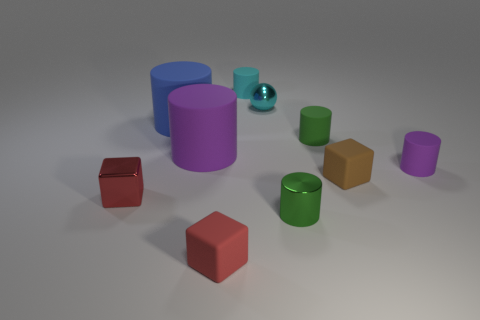There is a tiny thing that is the same color as the tiny ball; what is it made of?
Make the answer very short. Rubber. Is the size of the cyan sphere the same as the purple rubber cylinder that is left of the small cyan rubber thing?
Give a very brief answer. No. What number of metal things are either small green cylinders or tiny red things?
Your answer should be compact. 2. Are there more rubber objects than large gray rubber things?
Keep it short and to the point. Yes. The object that is the same color as the metallic block is what size?
Provide a short and direct response. Small. What is the shape of the shiny thing that is behind the purple thing that is in front of the big purple rubber cylinder?
Your answer should be very brief. Sphere. There is a red block behind the block that is in front of the metallic cube; are there any tiny matte cubes that are behind it?
Provide a short and direct response. Yes. There is a cylinder that is the same size as the blue rubber thing; what color is it?
Keep it short and to the point. Purple. There is a metal object that is both behind the small green shiny cylinder and to the right of the cyan cylinder; what is its shape?
Provide a short and direct response. Sphere. There is a green rubber cylinder to the right of the big rubber cylinder that is in front of the blue matte cylinder; what size is it?
Your response must be concise. Small. 